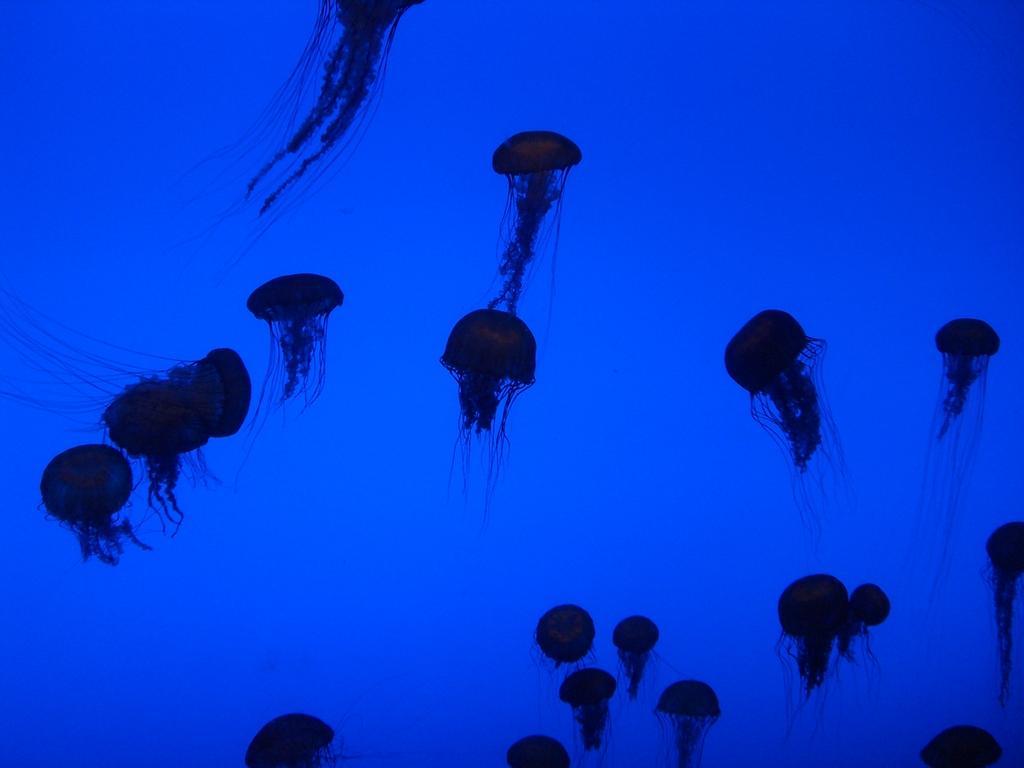Can you describe this image briefly? In this image we can see the jellyfishes. 